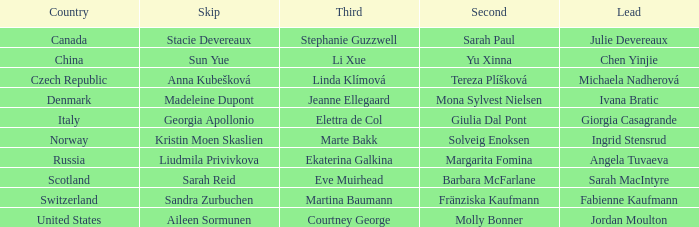What skip has angela tuvaeva as the lead? Liudmila Privivkova. 